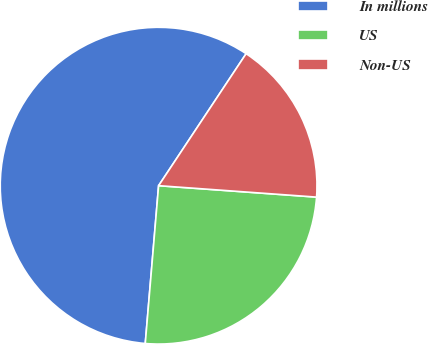Convert chart. <chart><loc_0><loc_0><loc_500><loc_500><pie_chart><fcel>In millions<fcel>US<fcel>Non-US<nl><fcel>57.97%<fcel>25.19%<fcel>16.83%<nl></chart> 